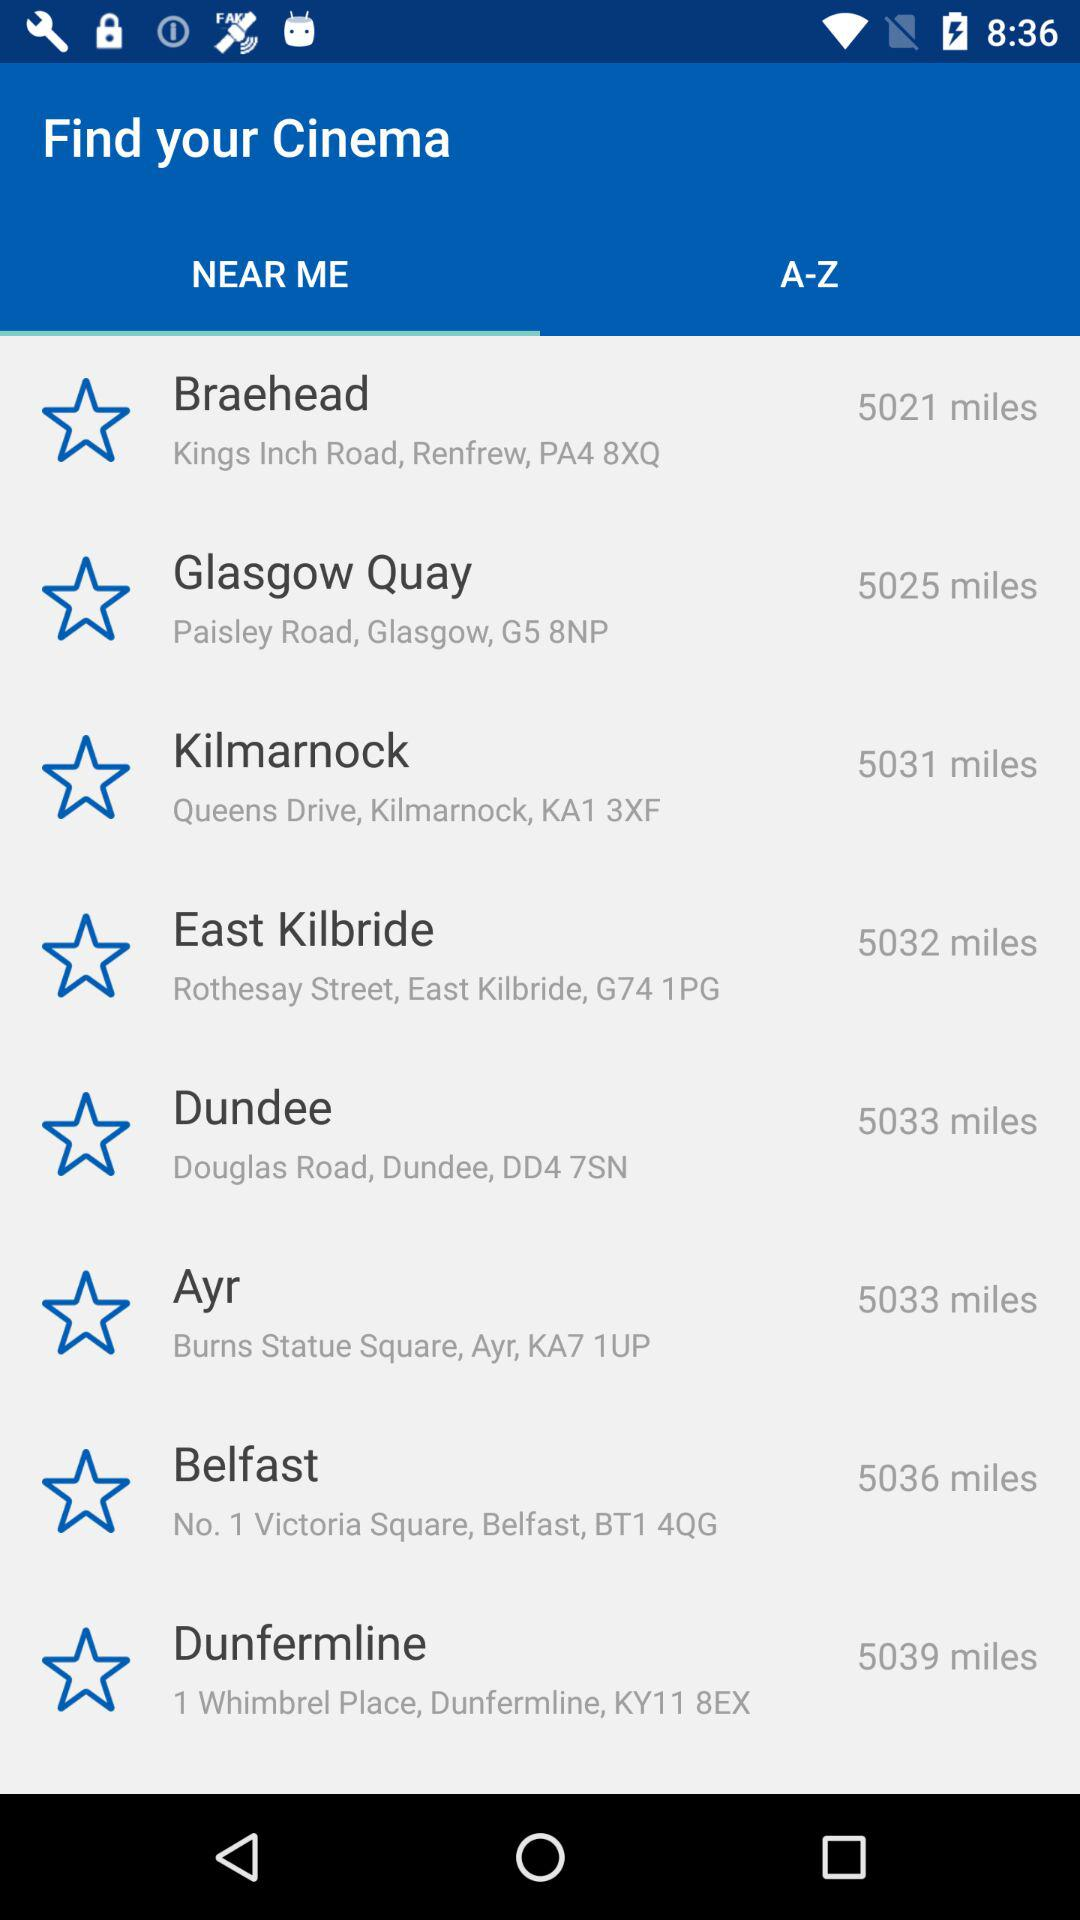How many miles away is the cinema with the shortest distance?
Answer the question using a single word or phrase. 5021 